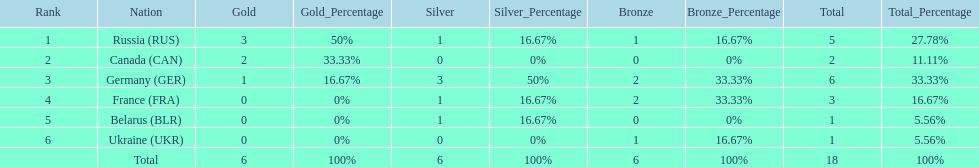Name the country that had the same number of bronze medals as russia. Ukraine. 